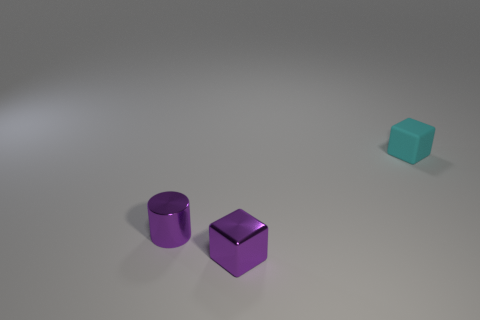What number of large things are blue cylinders or metal cubes?
Offer a very short reply. 0. What color is the tiny cylinder?
Offer a very short reply. Purple. What shape is the small purple metallic thing that is in front of the small purple thing behind the metal cube?
Provide a succinct answer. Cube. Are there any blue things that have the same material as the cyan thing?
Provide a succinct answer. No. There is a cube that is in front of the cyan rubber thing; is it the same size as the small purple cylinder?
Offer a terse response. Yes. How many purple objects are either cylinders or tiny metallic blocks?
Your response must be concise. 2. What is the material of the tiny block right of the purple block?
Offer a terse response. Rubber. There is a tiny block to the left of the small rubber cube; what number of purple metal things are in front of it?
Make the answer very short. 0. How many tiny purple things are the same shape as the small cyan object?
Ensure brevity in your answer.  1. How many small blue rubber cylinders are there?
Offer a very short reply. 0. 